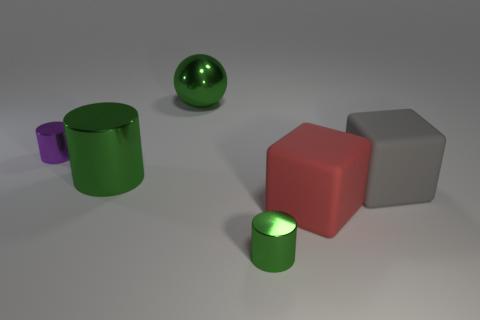Subtract all green metallic cylinders. How many cylinders are left? 1 Subtract 1 cylinders. How many cylinders are left? 2 Add 3 large cubes. How many objects exist? 9 Subtract all red cubes. How many cubes are left? 1 Subtract all cubes. How many objects are left? 4 Add 2 large cubes. How many large cubes are left? 4 Add 6 blue metallic spheres. How many blue metallic spheres exist? 6 Subtract 0 purple balls. How many objects are left? 6 Subtract all green blocks. Subtract all yellow balls. How many blocks are left? 2 Subtract all yellow blocks. How many gray balls are left? 0 